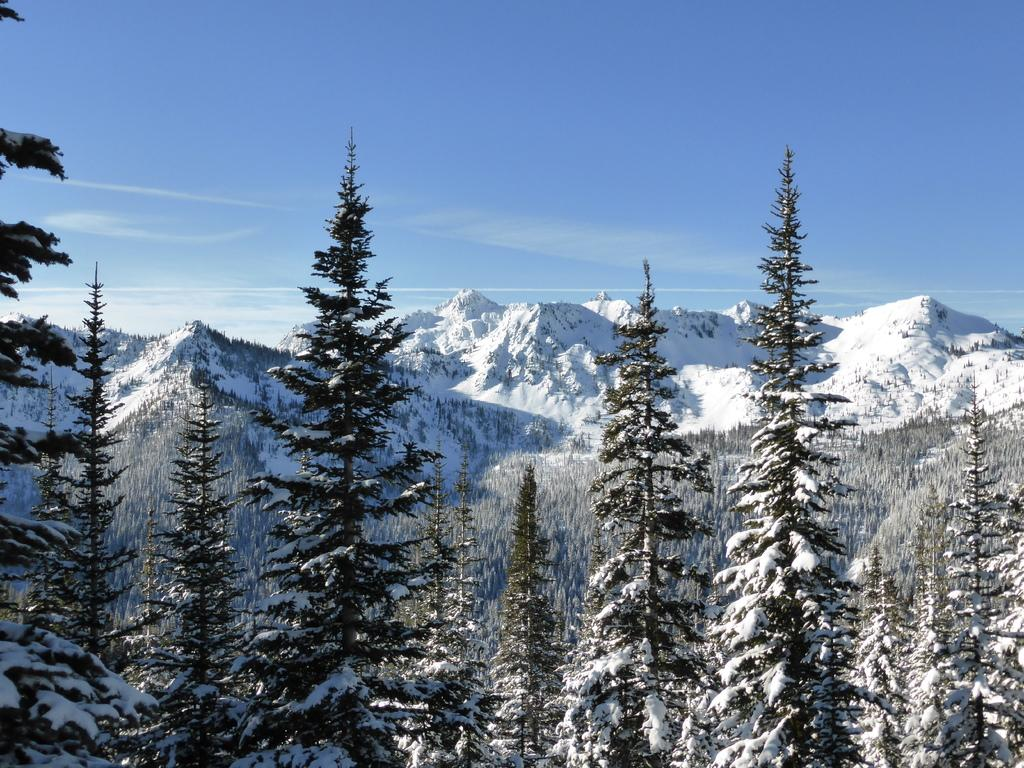What type of trees are visible in the image? There are trees with snow on them in the image. Where are the snow-covered trees located in the image? The snow-covered trees are in the background of the image. What else can be seen in the background of the image? There are mountains covered with snow and the sky visible in the background of the image. What is the condition of the sky in the image? Clouds are present in the sky. What type of furniture can be seen in the image? There is no furniture present in the image; it features snow-covered trees, mountains, and a sky with clouds. How many crates are visible in the image? There are no crates present in the image. 